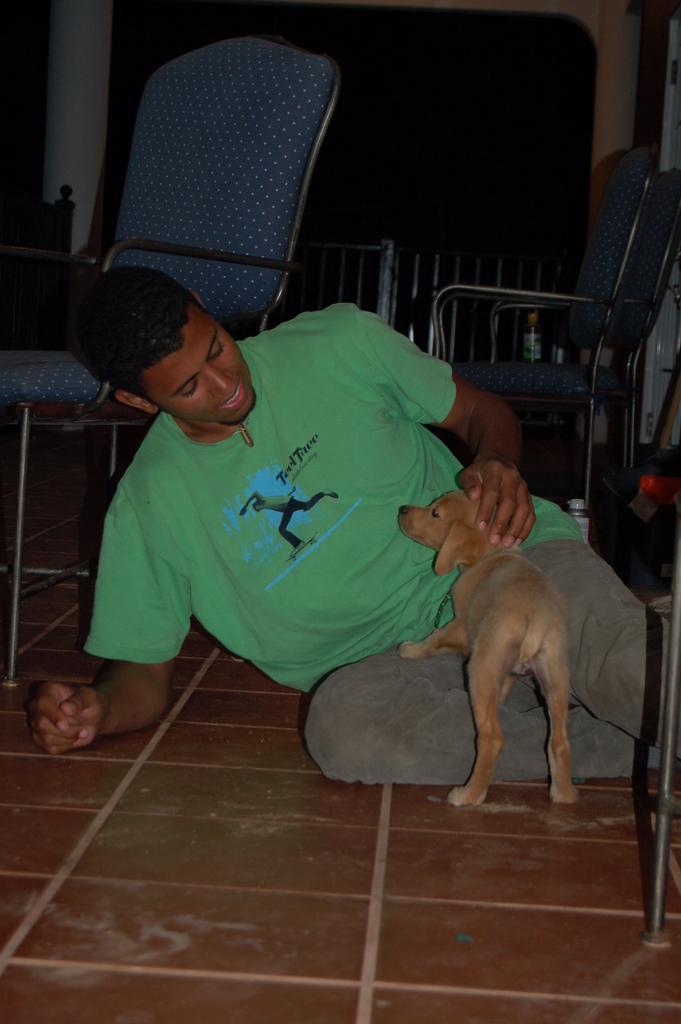Describe this image in one or two sentences. Here we can see a man who is sitting on the floor. There is a dog and these are the chairs. 